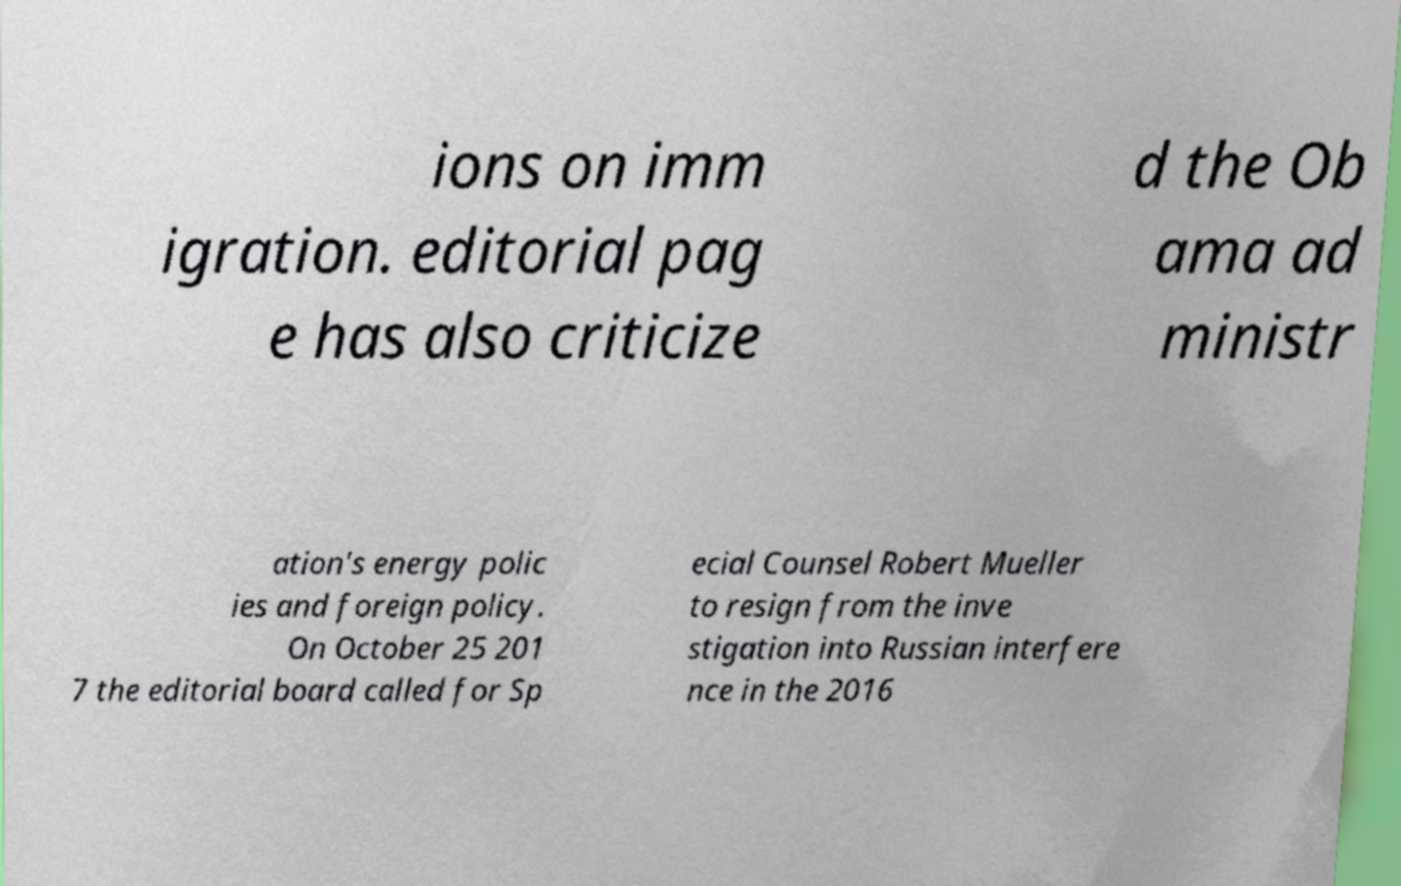What messages or text are displayed in this image? I need them in a readable, typed format. ions on imm igration. editorial pag e has also criticize d the Ob ama ad ministr ation's energy polic ies and foreign policy. On October 25 201 7 the editorial board called for Sp ecial Counsel Robert Mueller to resign from the inve stigation into Russian interfere nce in the 2016 